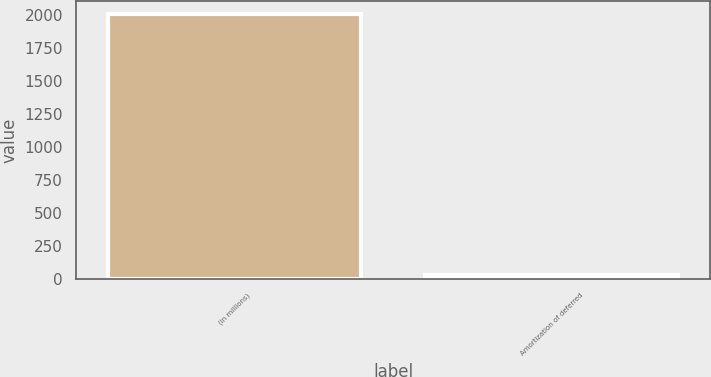Convert chart. <chart><loc_0><loc_0><loc_500><loc_500><bar_chart><fcel>(in millions)<fcel>Amortization of deferred<nl><fcel>2010<fcel>30<nl></chart> 